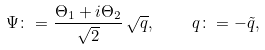<formula> <loc_0><loc_0><loc_500><loc_500>\Psi \colon = \frac { \Theta _ { 1 } + i \Theta _ { 2 } } { \sqrt { 2 } } \, \sqrt { q } , \quad q \colon = - \tilde { q } ,</formula> 